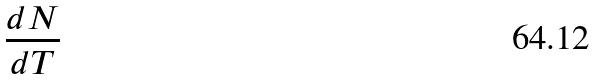Convert formula to latex. <formula><loc_0><loc_0><loc_500><loc_500>\frac { d N } { d T }</formula> 